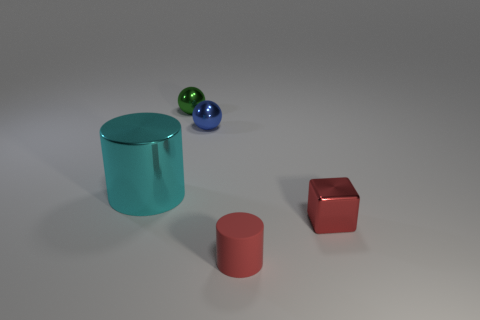Add 4 tiny green things. How many objects exist? 9 Subtract all spheres. How many objects are left? 3 Add 3 blue metal spheres. How many blue metal spheres are left? 4 Add 5 cyan shiny balls. How many cyan shiny balls exist? 5 Subtract 0 gray spheres. How many objects are left? 5 Subtract all tiny spheres. Subtract all big things. How many objects are left? 2 